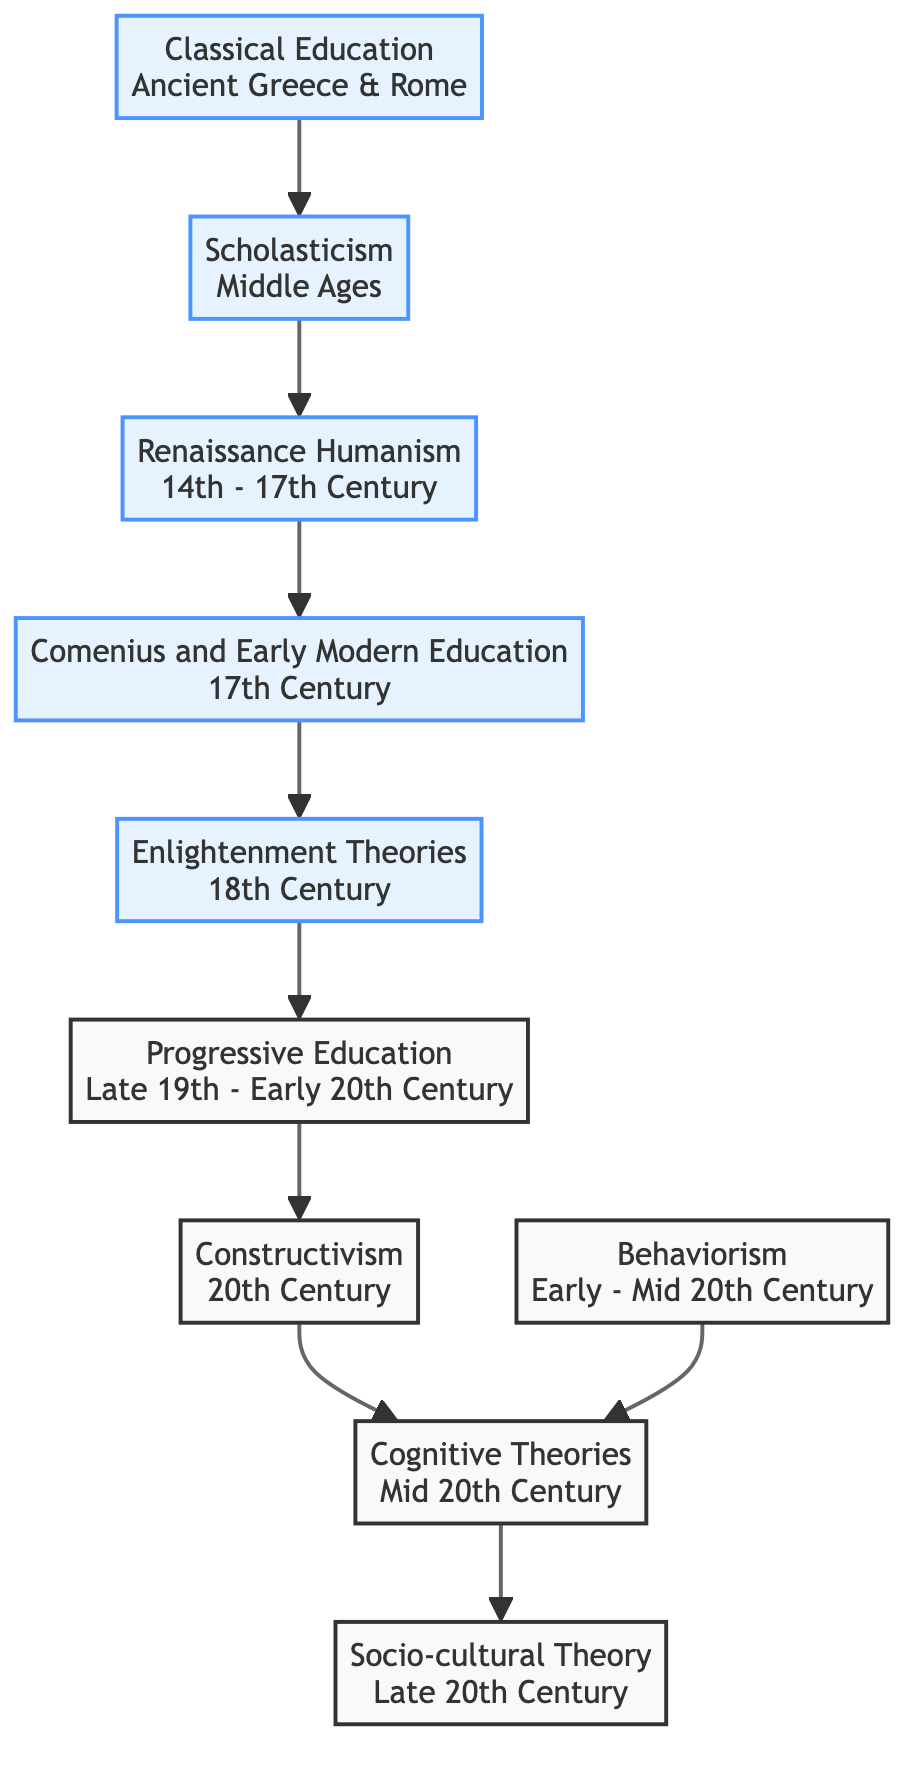What's the time period for Classical Education? The diagram specifies that Classical Education is from Ancient Greece & Rome, which is explicitly mentioned in the node description.
Answer: Ancient Greece & Rome Who are the key contributors to Constructivism? The diagram lists Jean Piaget and Lev Vygotsky as the key contributors to Constructivism in the corresponding node.
Answer: Jean Piaget, Lev Vygotsky How many connections are there in the diagram? By counting the connections listed in the connections section of the diagram, I find a total of 9 connections between nodes.
Answer: 9 What educational theory follows Enlightenment Theories? Following the connection from Enlightenment Theories in the diagram, the next node is Progressive Education, as indicated by the directional arrow.
Answer: Progressive Education Which theory emphasizes hands-on learning? The description of Comenius and Early Modern Education in the diagram highlights advocacy for universal education and hands-on learning, clearly identifying it as the focus of that theory.
Answer: Comenius and Early Modern Education In which century did Behaviorism emerge? The node for Behaviorism specifies that it emerged during the Early to Mid 20th Century, directly referenced in the time period provided.
Answer: Early - Mid 20th Century What is the relationship between Constructivism and Cognitive Theories? The diagram shows a direct connection with an arrow going from Constructivism to Cognitive Theories, indicating that Cognitive Theories follows Constructivism in the progression of educational theories.
Answer: Constructivism leads to Cognitive Theories Which theory has Socrates as a key contributor? The diagram indicates that Socrates is a key contributor to Classical Education, shown directly within the node's contributors list.
Answer: Classical Education What is the key focus of the Sociocultural Theory? The diagram's node for Socio-cultural Theory describes its focus on the importance of social interactions and cultural context in learning, explicitly outlining its main focus.
Answer: Social interactions and cultural context 